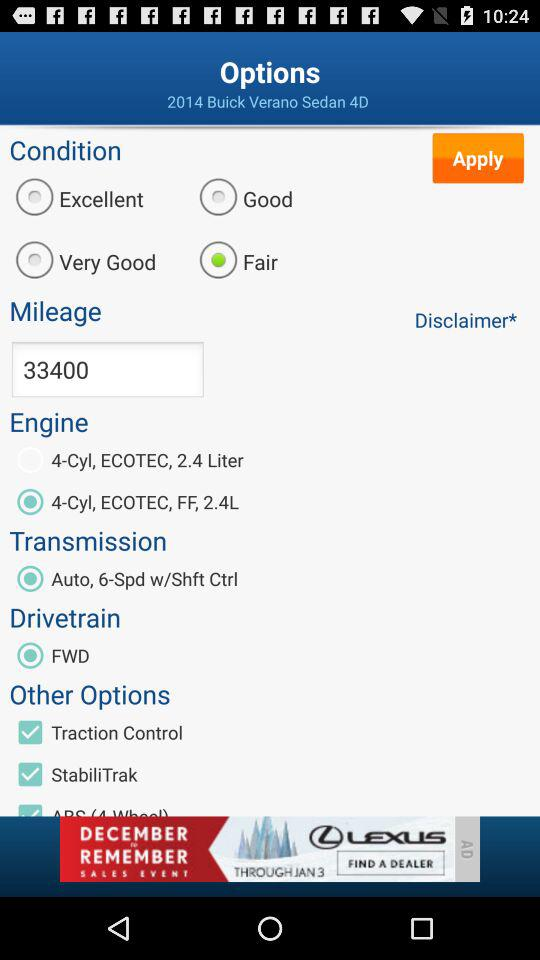What is the model number of the vehicle? The model number is "2014 Buick Verano Sedan 4D". 